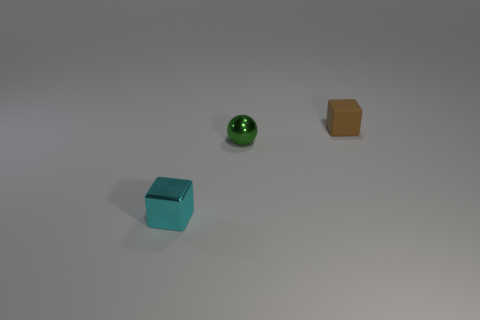Is there anything else that is the same color as the metal block? The spherical object to the right of the metal block shares a similar hue but is not an exact match in color due to differences in material and light reflection. 